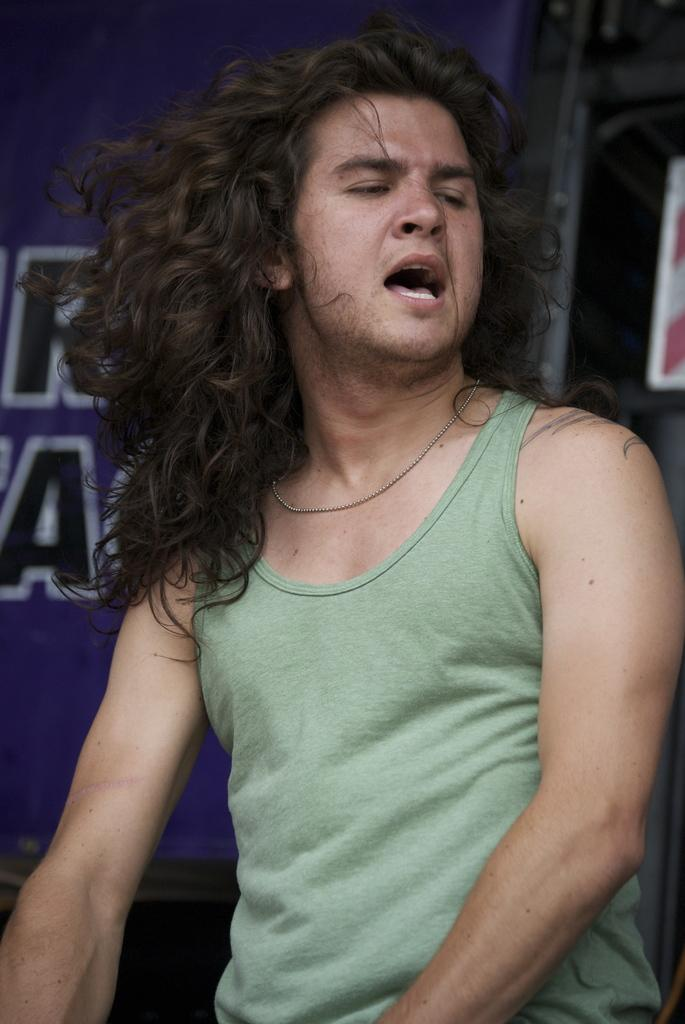Who is the main subject in the image? There is a man in the center of the image. What can be seen in the background of the image? There is a board in the background of the image. What type of lipstick is the man wearing in the image? The man is not wearing lipstick in the image, as there is no reference to any cosmetics or makeup. 